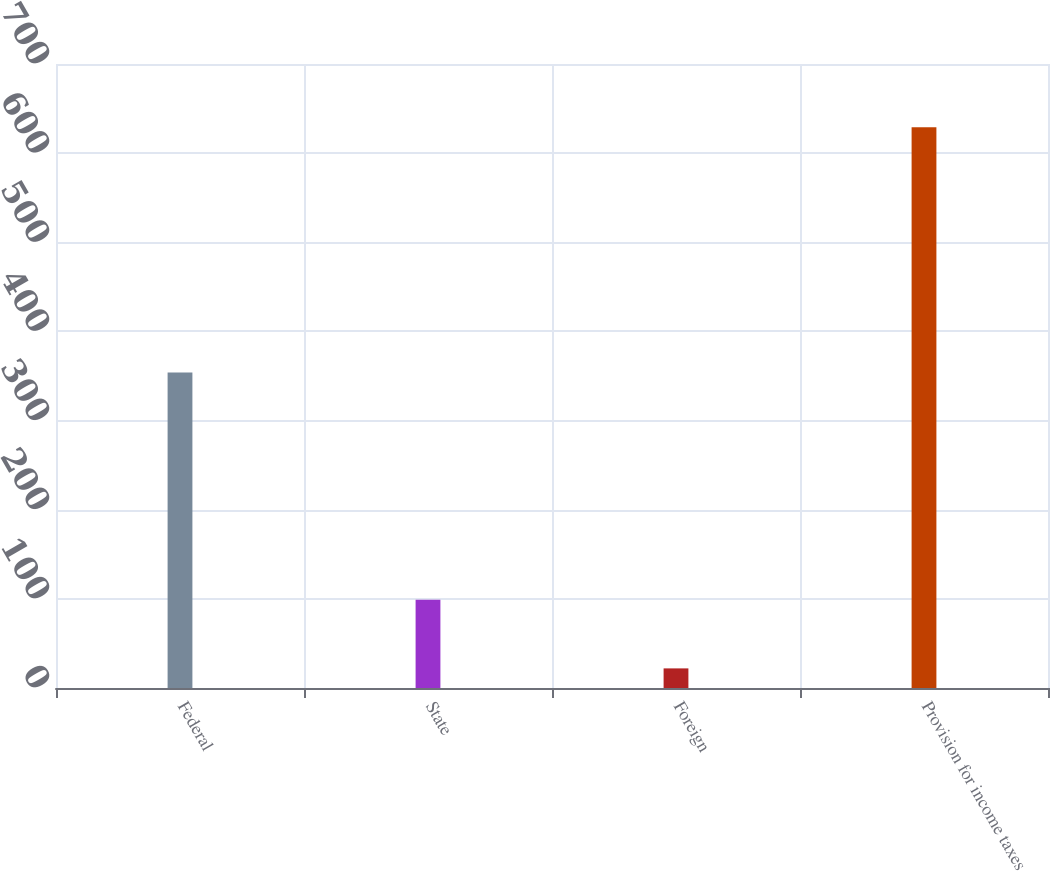<chart> <loc_0><loc_0><loc_500><loc_500><bar_chart><fcel>Federal<fcel>State<fcel>Foreign<fcel>Provision for income taxes<nl><fcel>354<fcel>99<fcel>22<fcel>629<nl></chart> 